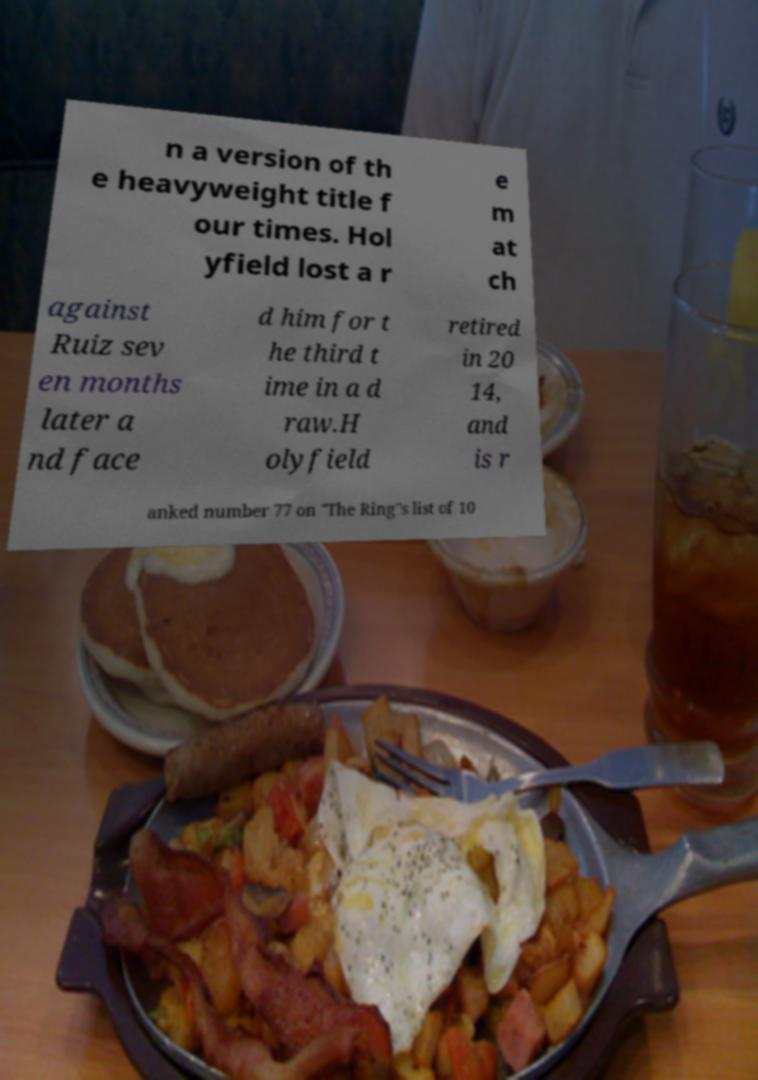Could you assist in decoding the text presented in this image and type it out clearly? n a version of th e heavyweight title f our times. Hol yfield lost a r e m at ch against Ruiz sev en months later a nd face d him for t he third t ime in a d raw.H olyfield retired in 20 14, and is r anked number 77 on "The Ring"s list of 10 